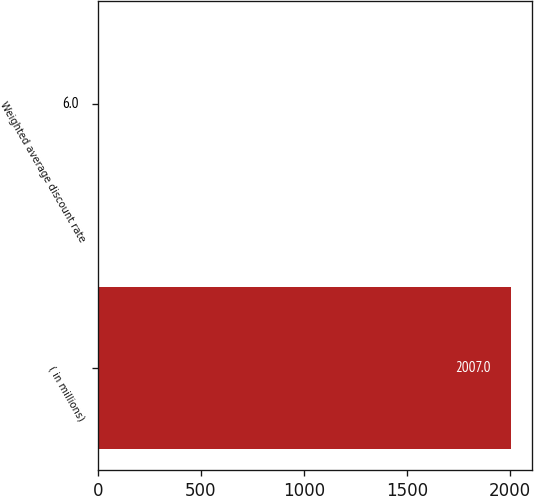<chart> <loc_0><loc_0><loc_500><loc_500><bar_chart><fcel>( in millions)<fcel>Weighted average discount rate<nl><fcel>2007<fcel>6<nl></chart> 